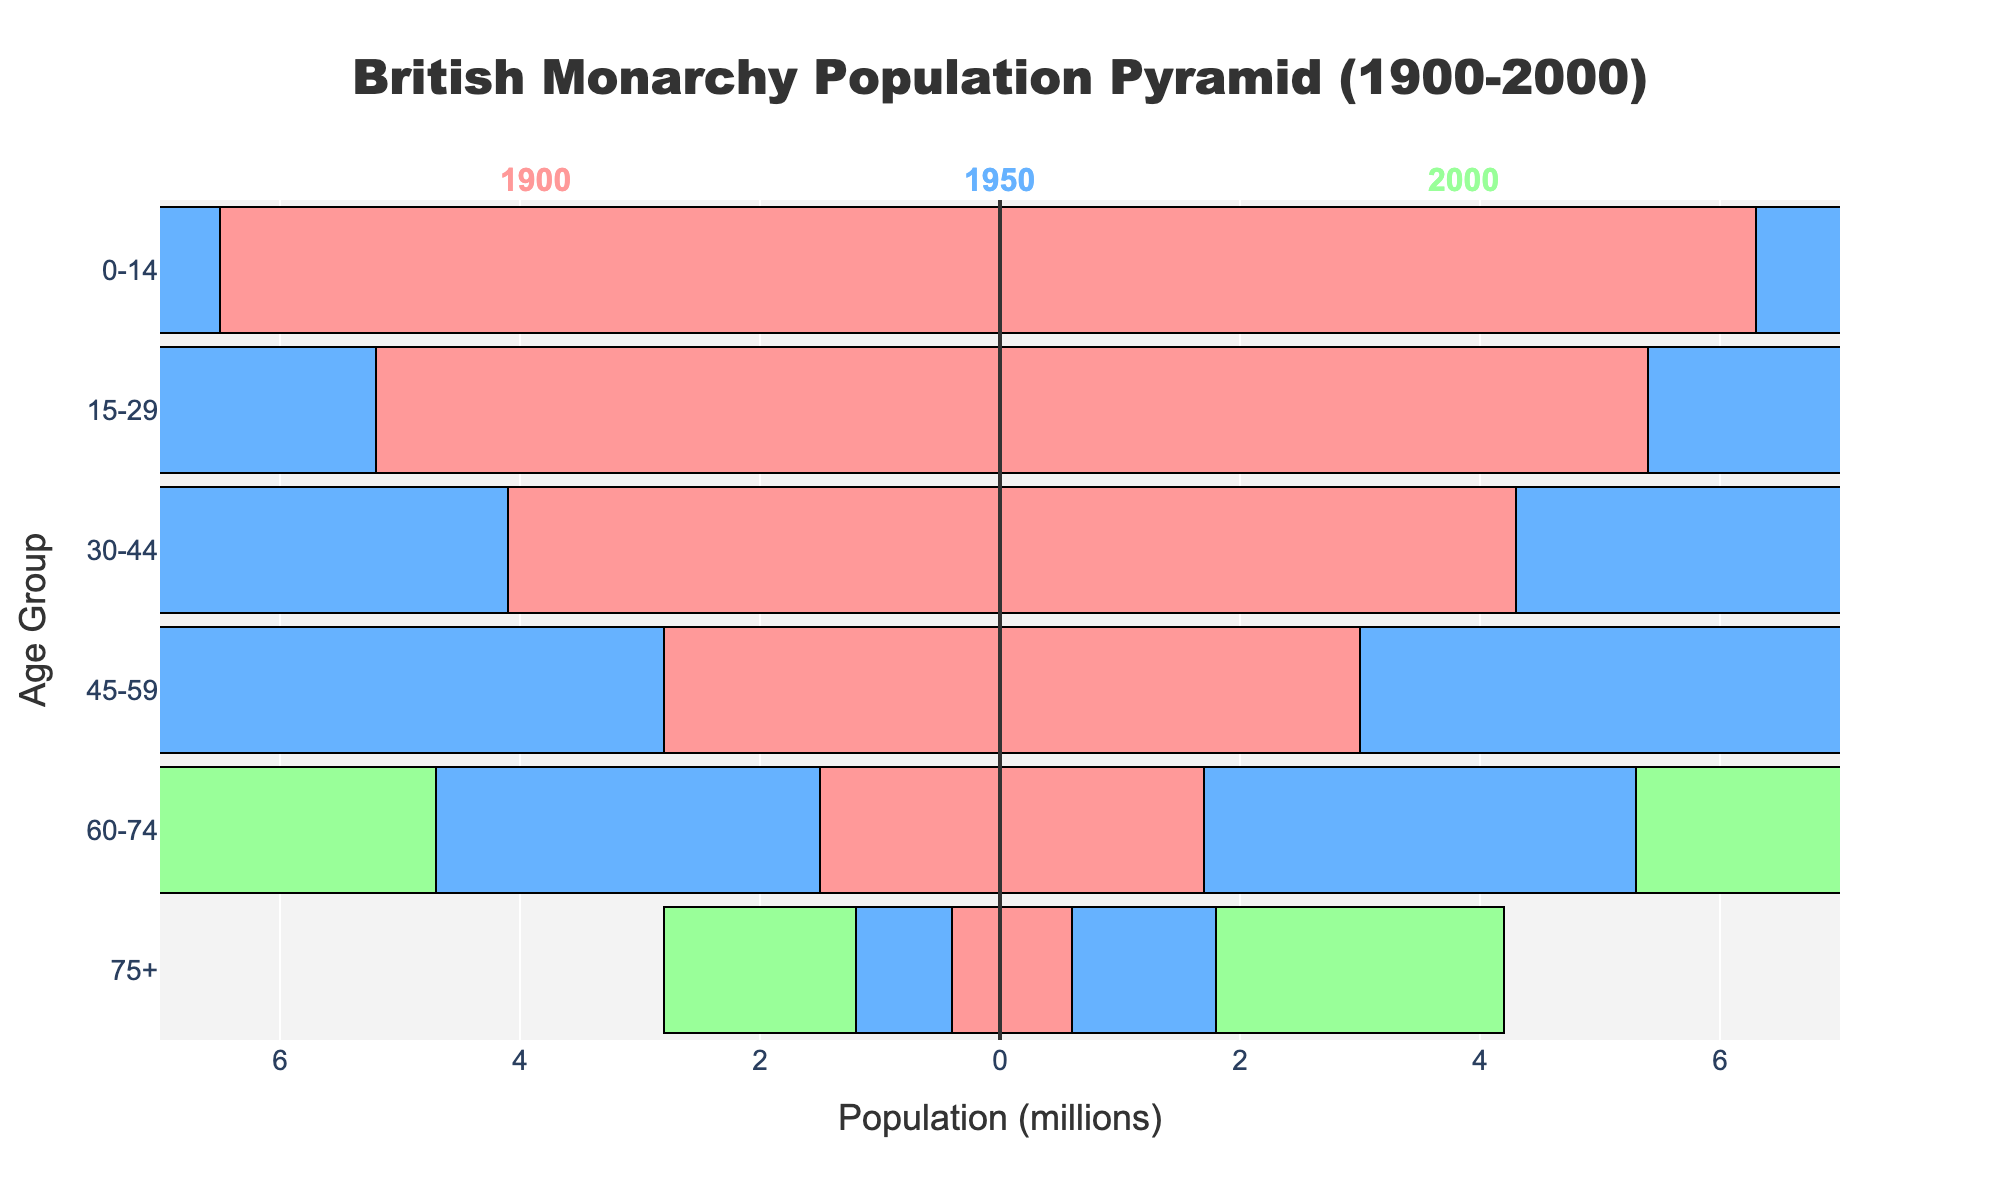What is the title of the population pyramid? The title is usually displayed at the top of the figure and summarizes the content.
Answer: British Monarchy Population Pyramid (1900-2000) How many age groups are displayed in the pyramid? The age groups are indicated on the vertical axis (Y-axis) of the pyramid. Counting them gives the total number.
Answer: 6 What color represents the population data for the year 2000? Each year is represented by a distinct color in the pyramid.
Answer: Green Which age group had the largest male population in the year 1950? By looking at the length of the bars for males in 1950 (colored blue), we can identify the longest bar.
Answer: 30-44 How did the population of females aged 75+ change from 1900 to 2000? Compare the lengths of the bars for females aged 75+ in 1900 and 2000 (colored pink and green, respectively).
Answer: Increased Which gender had a larger population in the 15-29 age group in 1900? Compare the blue and pink bars for the 15-29 age group in 1900 to see which one is longer.
Answer: Female Did the male population increase or decrease in the 45-59 age group from 1900 to 1950? Compare the lengths of the blue bars for males in the 45-59 age group from 1900 to 1950.
Answer: Increased What is the range of the population scale on the X-axis in millions? The labels on the X-axis give the range, showing population numbers in millions.
Answer: -7 to 7 Compare the total population of males and females in the 30-44 age group in 2000. Add the male and female populations for the 30-44 age group in 2000 and compare the totals.
Answer: Males had 6.2M and females had 6.3M, so females slightly more Which age group had the smallest female population in 1950? By looking at the lengths of the bars for females in 1950 (colored blue), we can identify the shortest bar.
Answer: 0-14 